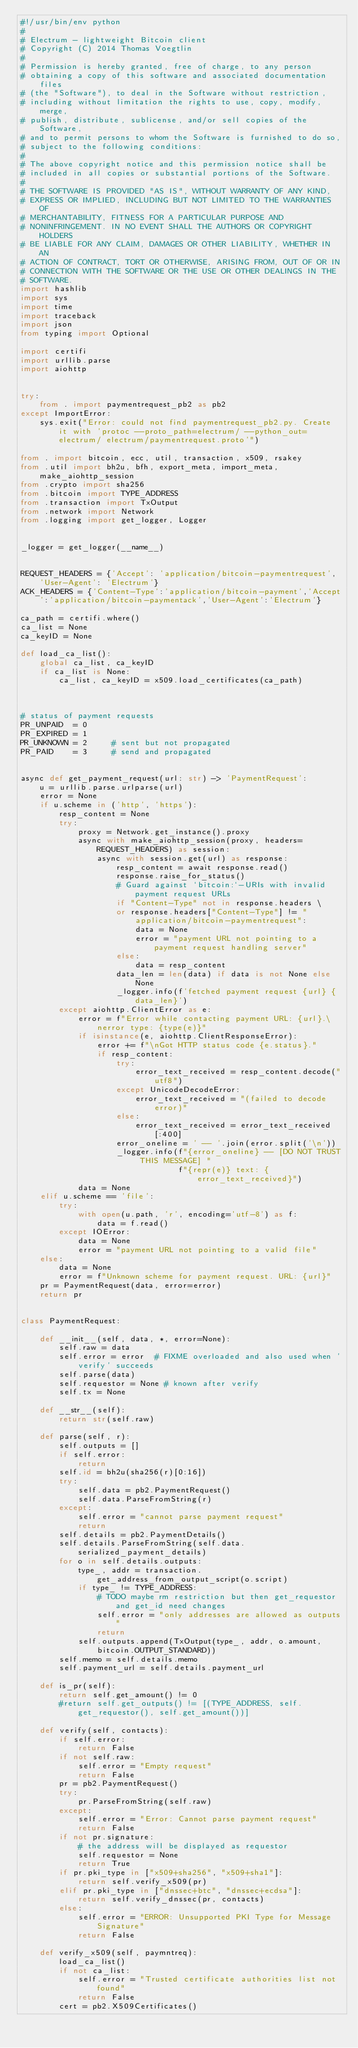Convert code to text. <code><loc_0><loc_0><loc_500><loc_500><_Python_>#!/usr/bin/env python
#
# Electrum - lightweight Bitcoin client
# Copyright (C) 2014 Thomas Voegtlin
#
# Permission is hereby granted, free of charge, to any person
# obtaining a copy of this software and associated documentation files
# (the "Software"), to deal in the Software without restriction,
# including without limitation the rights to use, copy, modify, merge,
# publish, distribute, sublicense, and/or sell copies of the Software,
# and to permit persons to whom the Software is furnished to do so,
# subject to the following conditions:
#
# The above copyright notice and this permission notice shall be
# included in all copies or substantial portions of the Software.
#
# THE SOFTWARE IS PROVIDED "AS IS", WITHOUT WARRANTY OF ANY KIND,
# EXPRESS OR IMPLIED, INCLUDING BUT NOT LIMITED TO THE WARRANTIES OF
# MERCHANTABILITY, FITNESS FOR A PARTICULAR PURPOSE AND
# NONINFRINGEMENT. IN NO EVENT SHALL THE AUTHORS OR COPYRIGHT HOLDERS
# BE LIABLE FOR ANY CLAIM, DAMAGES OR OTHER LIABILITY, WHETHER IN AN
# ACTION OF CONTRACT, TORT OR OTHERWISE, ARISING FROM, OUT OF OR IN
# CONNECTION WITH THE SOFTWARE OR THE USE OR OTHER DEALINGS IN THE
# SOFTWARE.
import hashlib
import sys
import time
import traceback
import json
from typing import Optional

import certifi
import urllib.parse
import aiohttp


try:
    from . import paymentrequest_pb2 as pb2
except ImportError:
    sys.exit("Error: could not find paymentrequest_pb2.py. Create it with 'protoc --proto_path=electrum/ --python_out=electrum/ electrum/paymentrequest.proto'")

from . import bitcoin, ecc, util, transaction, x509, rsakey
from .util import bh2u, bfh, export_meta, import_meta, make_aiohttp_session
from .crypto import sha256
from .bitcoin import TYPE_ADDRESS
from .transaction import TxOutput
from .network import Network
from .logging import get_logger, Logger


_logger = get_logger(__name__)


REQUEST_HEADERS = {'Accept': 'application/bitcoin-paymentrequest', 'User-Agent': 'Electrum'}
ACK_HEADERS = {'Content-Type':'application/bitcoin-payment','Accept':'application/bitcoin-paymentack','User-Agent':'Electrum'}

ca_path = certifi.where()
ca_list = None
ca_keyID = None

def load_ca_list():
    global ca_list, ca_keyID
    if ca_list is None:
        ca_list, ca_keyID = x509.load_certificates(ca_path)



# status of payment requests
PR_UNPAID  = 0
PR_EXPIRED = 1
PR_UNKNOWN = 2     # sent but not propagated
PR_PAID    = 3     # send and propagated


async def get_payment_request(url: str) -> 'PaymentRequest':
    u = urllib.parse.urlparse(url)
    error = None
    if u.scheme in ('http', 'https'):
        resp_content = None
        try:
            proxy = Network.get_instance().proxy
            async with make_aiohttp_session(proxy, headers=REQUEST_HEADERS) as session:
                async with session.get(url) as response:
                    resp_content = await response.read()
                    response.raise_for_status()
                    # Guard against `bitcoin:`-URIs with invalid payment request URLs
                    if "Content-Type" not in response.headers \
                    or response.headers["Content-Type"] != "application/bitcoin-paymentrequest":
                        data = None
                        error = "payment URL not pointing to a payment request handling server"
                    else:
                        data = resp_content
                    data_len = len(data) if data is not None else None
                    _logger.info(f'fetched payment request {url} {data_len}')
        except aiohttp.ClientError as e:
            error = f"Error while contacting payment URL: {url}.\nerror type: {type(e)}"
            if isinstance(e, aiohttp.ClientResponseError):
                error += f"\nGot HTTP status code {e.status}."
                if resp_content:
                    try:
                        error_text_received = resp_content.decode("utf8")
                    except UnicodeDecodeError:
                        error_text_received = "(failed to decode error)"
                    else:
                        error_text_received = error_text_received[:400]
                    error_oneline = ' -- '.join(error.split('\n'))
                    _logger.info(f"{error_oneline} -- [DO NOT TRUST THIS MESSAGE] "
                                 f"{repr(e)} text: {error_text_received}")
            data = None
    elif u.scheme == 'file':
        try:
            with open(u.path, 'r', encoding='utf-8') as f:
                data = f.read()
        except IOError:
            data = None
            error = "payment URL not pointing to a valid file"
    else:
        data = None
        error = f"Unknown scheme for payment request. URL: {url}"
    pr = PaymentRequest(data, error=error)
    return pr


class PaymentRequest:

    def __init__(self, data, *, error=None):
        self.raw = data
        self.error = error  # FIXME overloaded and also used when 'verify' succeeds
        self.parse(data)
        self.requestor = None # known after verify
        self.tx = None

    def __str__(self):
        return str(self.raw)

    def parse(self, r):
        self.outputs = []
        if self.error:
            return
        self.id = bh2u(sha256(r)[0:16])
        try:
            self.data = pb2.PaymentRequest()
            self.data.ParseFromString(r)
        except:
            self.error = "cannot parse payment request"
            return
        self.details = pb2.PaymentDetails()
        self.details.ParseFromString(self.data.serialized_payment_details)
        for o in self.details.outputs:
            type_, addr = transaction.get_address_from_output_script(o.script)
            if type_ != TYPE_ADDRESS:
                # TODO maybe rm restriction but then get_requestor and get_id need changes
                self.error = "only addresses are allowed as outputs"
                return
            self.outputs.append(TxOutput(type_, addr, o.amount, bitcoin.OUTPUT_STANDARD))
        self.memo = self.details.memo
        self.payment_url = self.details.payment_url

    def is_pr(self):
        return self.get_amount() != 0
        #return self.get_outputs() != [(TYPE_ADDRESS, self.get_requestor(), self.get_amount())]

    def verify(self, contacts):
        if self.error:
            return False
        if not self.raw:
            self.error = "Empty request"
            return False
        pr = pb2.PaymentRequest()
        try:
            pr.ParseFromString(self.raw)
        except:
            self.error = "Error: Cannot parse payment request"
            return False
        if not pr.signature:
            # the address will be displayed as requestor
            self.requestor = None
            return True
        if pr.pki_type in ["x509+sha256", "x509+sha1"]:
            return self.verify_x509(pr)
        elif pr.pki_type in ["dnssec+btc", "dnssec+ecdsa"]:
            return self.verify_dnssec(pr, contacts)
        else:
            self.error = "ERROR: Unsupported PKI Type for Message Signature"
            return False

    def verify_x509(self, paymntreq):
        load_ca_list()
        if not ca_list:
            self.error = "Trusted certificate authorities list not found"
            return False
        cert = pb2.X509Certificates()</code> 